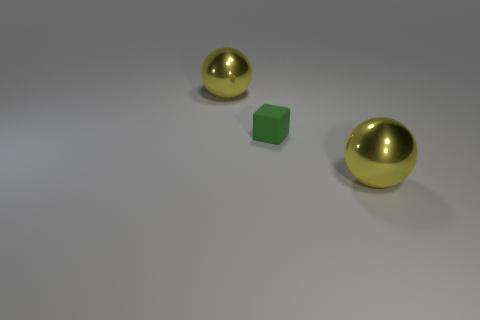Imagine these objects were part of a story. What narrative could they be telling? In a playful narrative, the two yellow spheres could represent characters on an adventure, with the green cube serving as a mysterious artifact or item of importance. The stark, plain background sets the stage for a world of imagination, where the journey of the spheres and their interaction with the cube could symbolize themes of friendship, discovery, and curiosity. 